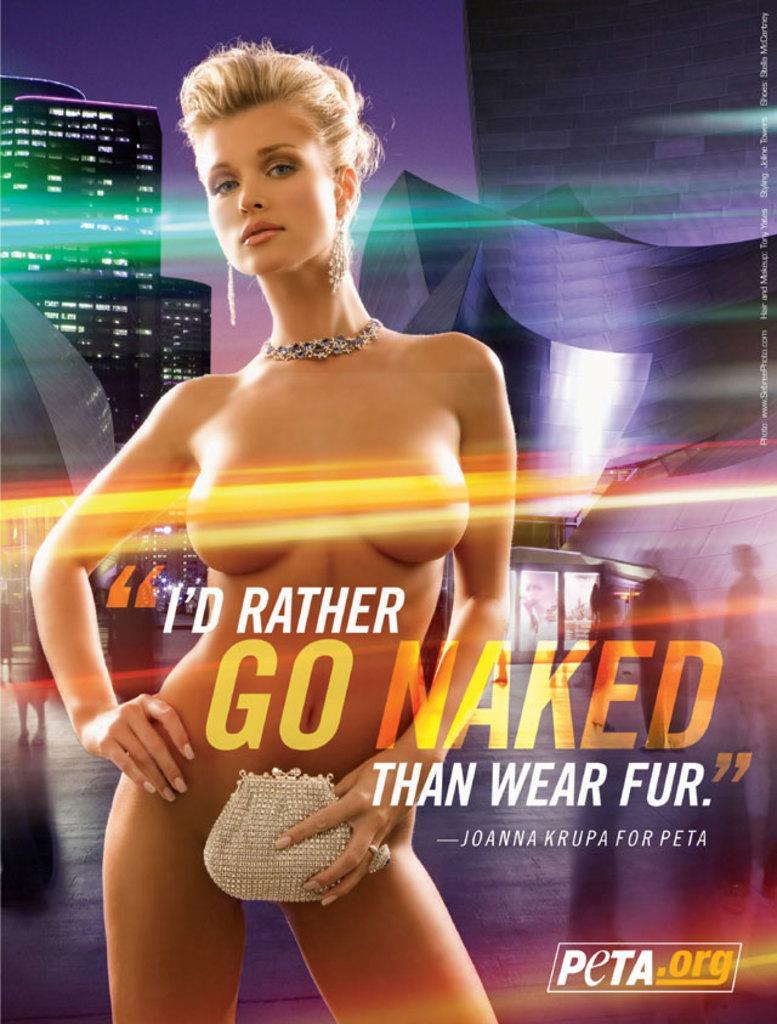Can you describe this image briefly? In the center of the image there is a woman. In the background there is a building, sky. 